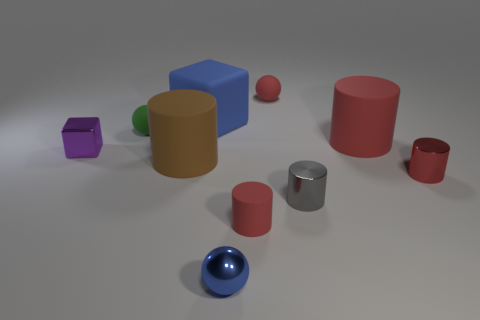Subtract all red cylinders. How many were subtracted if there are1red cylinders left? 2 Subtract all tiny metal balls. How many balls are left? 2 Subtract all blue spheres. How many spheres are left? 2 Subtract 0 purple balls. How many objects are left? 10 Subtract all balls. How many objects are left? 7 Subtract 3 cylinders. How many cylinders are left? 2 Subtract all green blocks. Subtract all yellow cylinders. How many blocks are left? 2 Subtract all cyan cylinders. How many blue cubes are left? 1 Subtract all metallic cylinders. Subtract all tiny purple cubes. How many objects are left? 7 Add 3 large red cylinders. How many large red cylinders are left? 4 